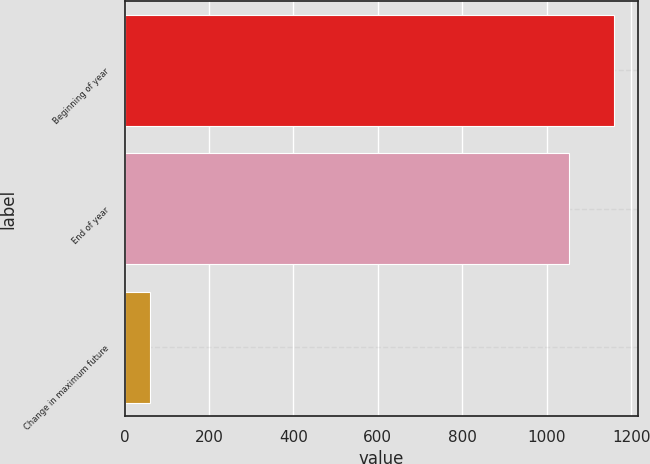Convert chart. <chart><loc_0><loc_0><loc_500><loc_500><bar_chart><fcel>Beginning of year<fcel>End of year<fcel>Change in maximum future<nl><fcel>1158.3<fcel>1053<fcel>59.6<nl></chart> 